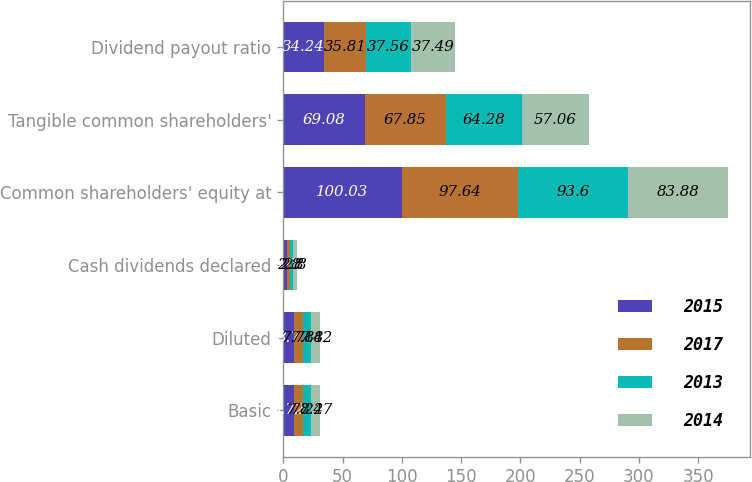<chart> <loc_0><loc_0><loc_500><loc_500><stacked_bar_chart><ecel><fcel>Basic<fcel>Diluted<fcel>Cash dividends declared<fcel>Common shareholders' equity at<fcel>Tangible common shareholders'<fcel>Dividend payout ratio<nl><fcel>2015<fcel>8.72<fcel>8.7<fcel>3<fcel>100.03<fcel>69.08<fcel>34.24<nl><fcel>2017<fcel>7.8<fcel>7.78<fcel>2.8<fcel>97.64<fcel>67.85<fcel>35.81<nl><fcel>2013<fcel>7.22<fcel>7.18<fcel>2.8<fcel>93.6<fcel>64.28<fcel>37.56<nl><fcel>2014<fcel>7.47<fcel>7.42<fcel>2.8<fcel>83.88<fcel>57.06<fcel>37.49<nl></chart> 